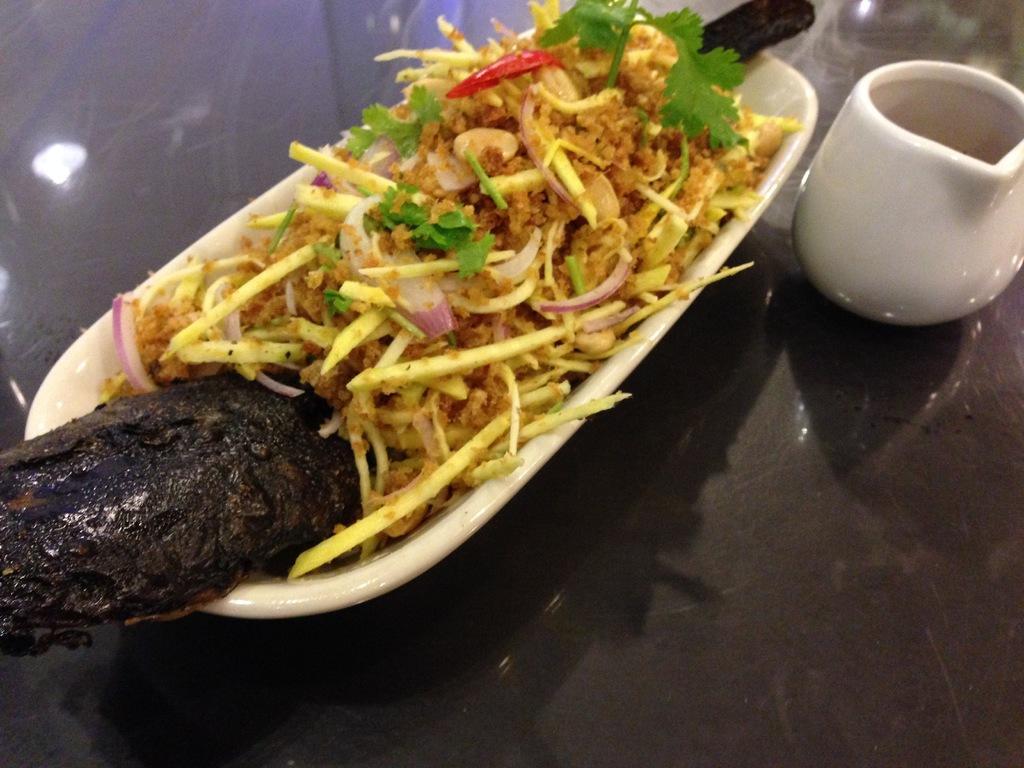Please provide a concise description of this image. In this image, we can see some food item is in the bowl. On the right side, we can see a cup. These things are placed on the black surface. 